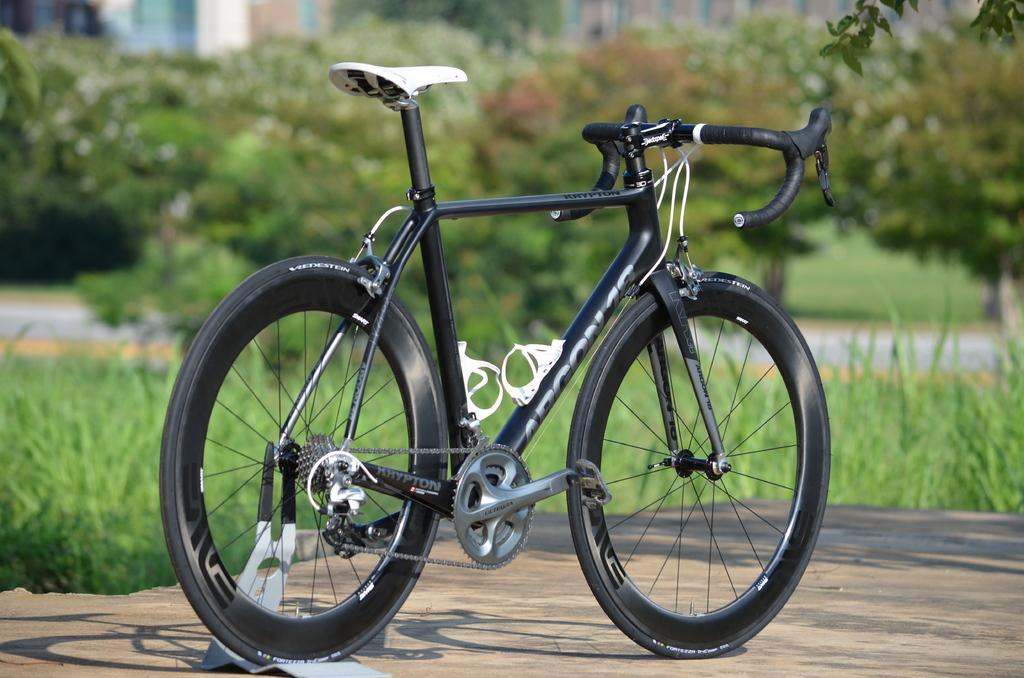What is the main object in the image? There is a bicycle in the image. What is the surface beneath the bicycle? The bicycle is on a stone surface. What can be seen in the background of the image? There is greenery and a road in the background of the image. What type of ink is being used to write on the stone surface in the image? There is no ink or writing present on the stone surface in the image. 